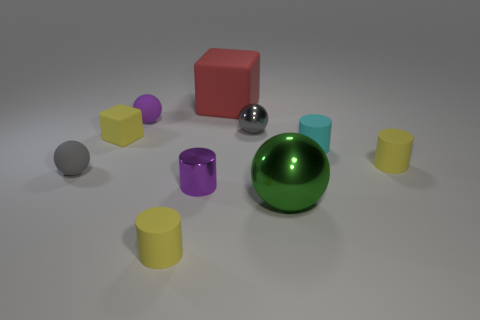Subtract 1 cylinders. How many cylinders are left? 3 Subtract all blue balls. Subtract all green cylinders. How many balls are left? 4 Subtract all balls. How many objects are left? 6 Add 5 brown cubes. How many brown cubes exist? 5 Subtract 0 blue cylinders. How many objects are left? 10 Subtract all yellow matte cubes. Subtract all small cyan matte objects. How many objects are left? 8 Add 4 big metallic spheres. How many big metallic spheres are left? 5 